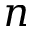<formula> <loc_0><loc_0><loc_500><loc_500>n</formula> 